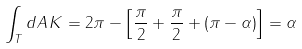Convert formula to latex. <formula><loc_0><loc_0><loc_500><loc_500>\int _ { T } d A \, K = 2 \pi - \left [ \frac { \pi } { 2 } + \frac { \pi } { 2 } + \left ( \pi - \alpha \right ) \right ] = \alpha</formula> 